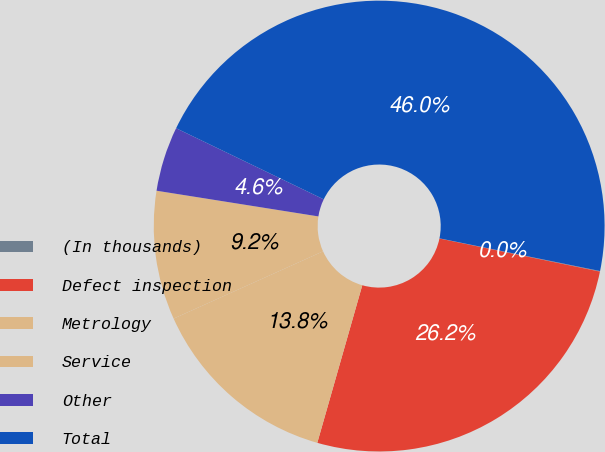Convert chart to OTSL. <chart><loc_0><loc_0><loc_500><loc_500><pie_chart><fcel>(In thousands)<fcel>Defect inspection<fcel>Metrology<fcel>Service<fcel>Other<fcel>Total<nl><fcel>0.04%<fcel>26.19%<fcel>13.84%<fcel>9.24%<fcel>4.64%<fcel>46.05%<nl></chart> 